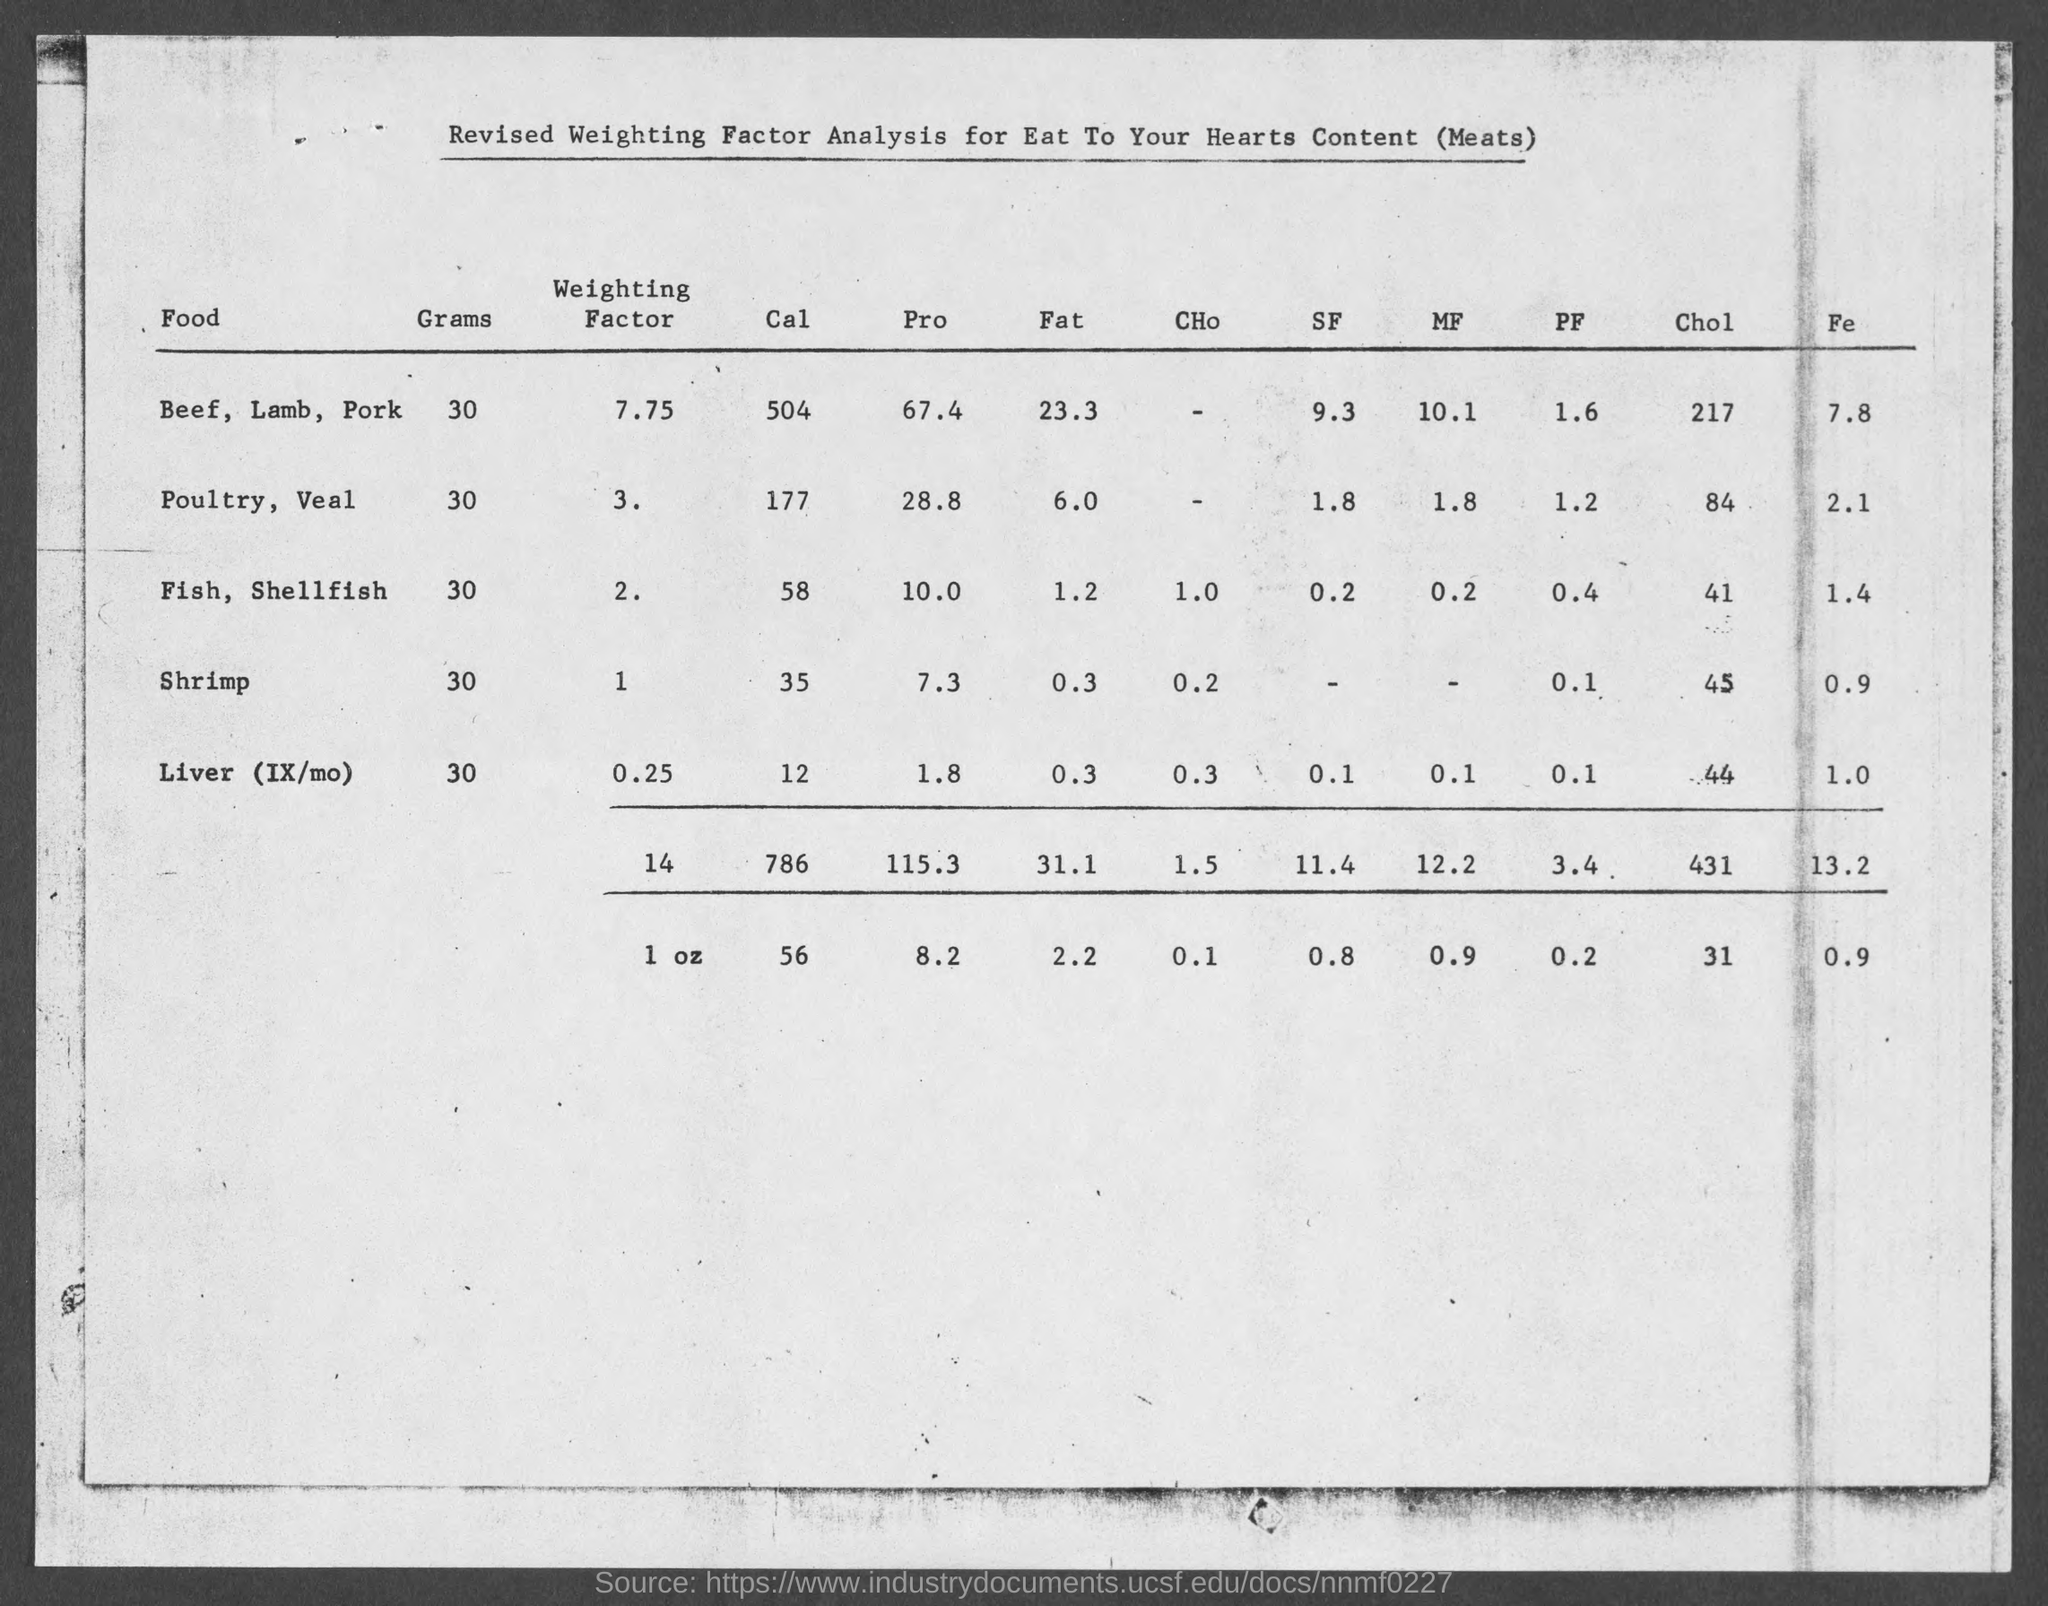How many calories does 30 grams of beef, lamb, pork have?
Provide a succinct answer. 504. How many calories does 30 grams of poultry, veal has?
Provide a succinct answer. 177. How many calories does 30 grams of fish, shellfish has?
Give a very brief answer. 58. How many calories does 30 grams of shrimp has?
Your answer should be compact. 35. How many calories does 30 grams of liver (ix/mo) has?
Offer a very short reply. 12. What amount of fat does 30 grams of beef, lamb, pork has?
Provide a succinct answer. 23.3. What amount of fat does 30 grams of poultry, veal has?
Your answer should be compact. 6.0. What amount of fat does 30 grams of fish, shellfish has?
Ensure brevity in your answer.  1.2. What amount of fat does 30 grams of shrimp has?
Give a very brief answer. 0.3. 